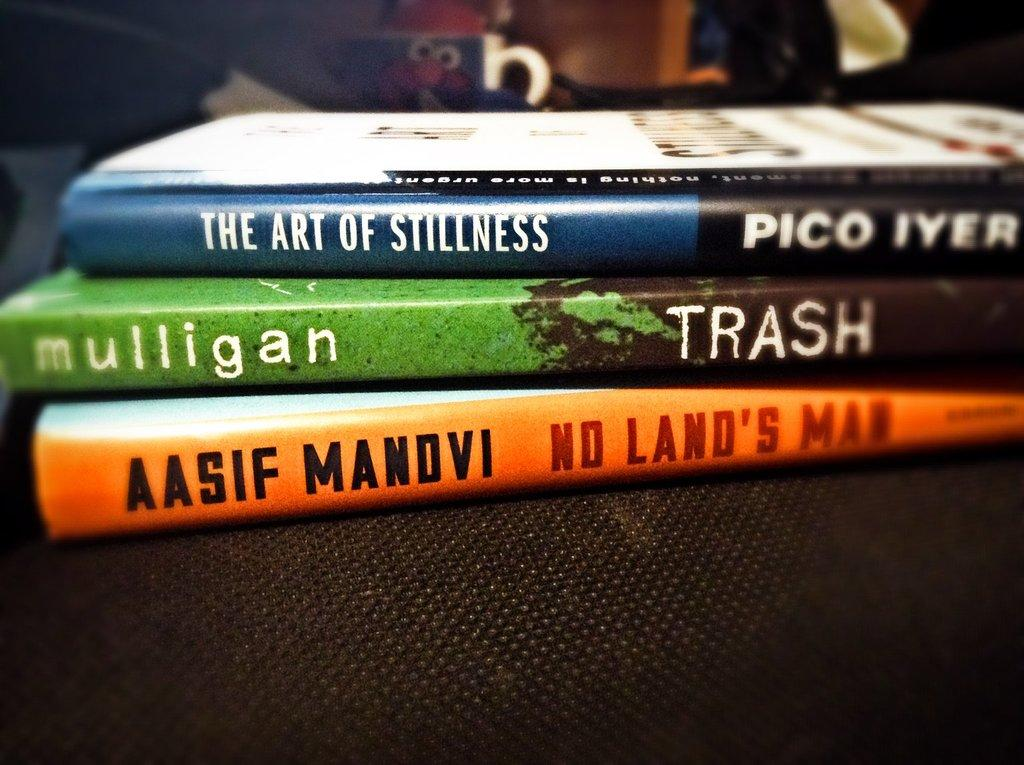What objects are placed on the table in the image? There are books placed on a table in the image. What can be seen in the background of the image? There is a cup in the background of the image, along with other objects. What type of donkey is sitting on the table in the image? There is no donkey present in the image; it only features books placed on a table and other objects in the background. 